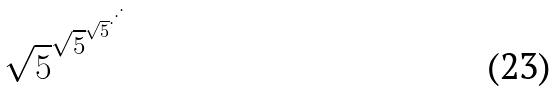<formula> <loc_0><loc_0><loc_500><loc_500>\sqrt { 5 } ^ { \sqrt { 5 } ^ { \sqrt { 5 } ^ { \cdot ^ { \cdot ^ { \cdot } } } } }</formula> 